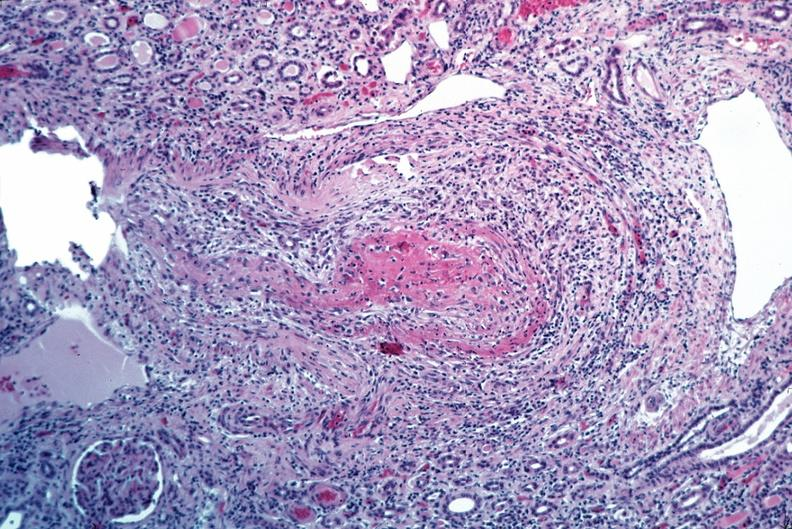s lesion present?
Answer the question using a single word or phrase. No 